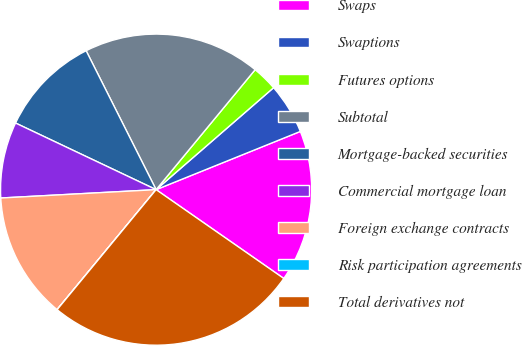Convert chart to OTSL. <chart><loc_0><loc_0><loc_500><loc_500><pie_chart><fcel>Swaps<fcel>Swaptions<fcel>Futures options<fcel>Subtotal<fcel>Mortgage-backed securities<fcel>Commercial mortgage loan<fcel>Foreign exchange contracts<fcel>Risk participation agreements<fcel>Total derivatives not<nl><fcel>15.78%<fcel>5.27%<fcel>2.64%<fcel>18.41%<fcel>10.53%<fcel>7.9%<fcel>13.16%<fcel>0.01%<fcel>26.3%<nl></chart> 